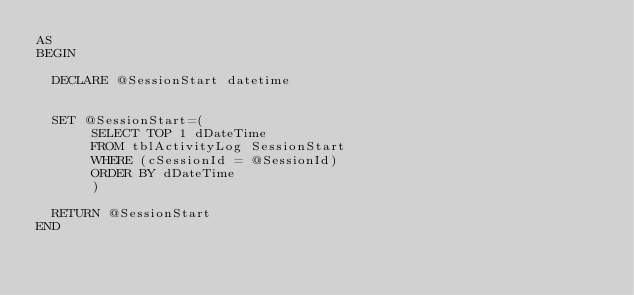Convert code to text. <code><loc_0><loc_0><loc_500><loc_500><_SQL_>AS
BEGIN

	DECLARE @SessionStart datetime


	SET @SessionStart=(
		   SELECT TOP 1 dDateTime 
		   FROM tblActivityLog SessionStart 
		   WHERE (cSessionId = @SessionId) 
		   ORDER BY dDateTime
		   )

	RETURN @SessionStart
END


</code> 